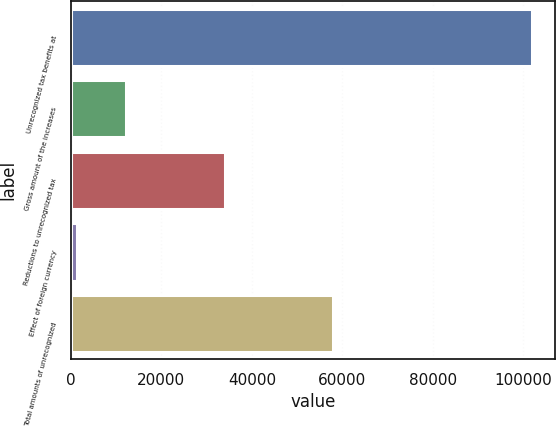<chart> <loc_0><loc_0><loc_500><loc_500><bar_chart><fcel>Unrecognized tax benefits at<fcel>Gross amount of the increases<fcel>Reductions to unrecognized tax<fcel>Effect of foreign currency<fcel>Total amounts of unrecognized<nl><fcel>101857<fcel>12214.9<fcel>33984.7<fcel>1330<fcel>58022<nl></chart> 